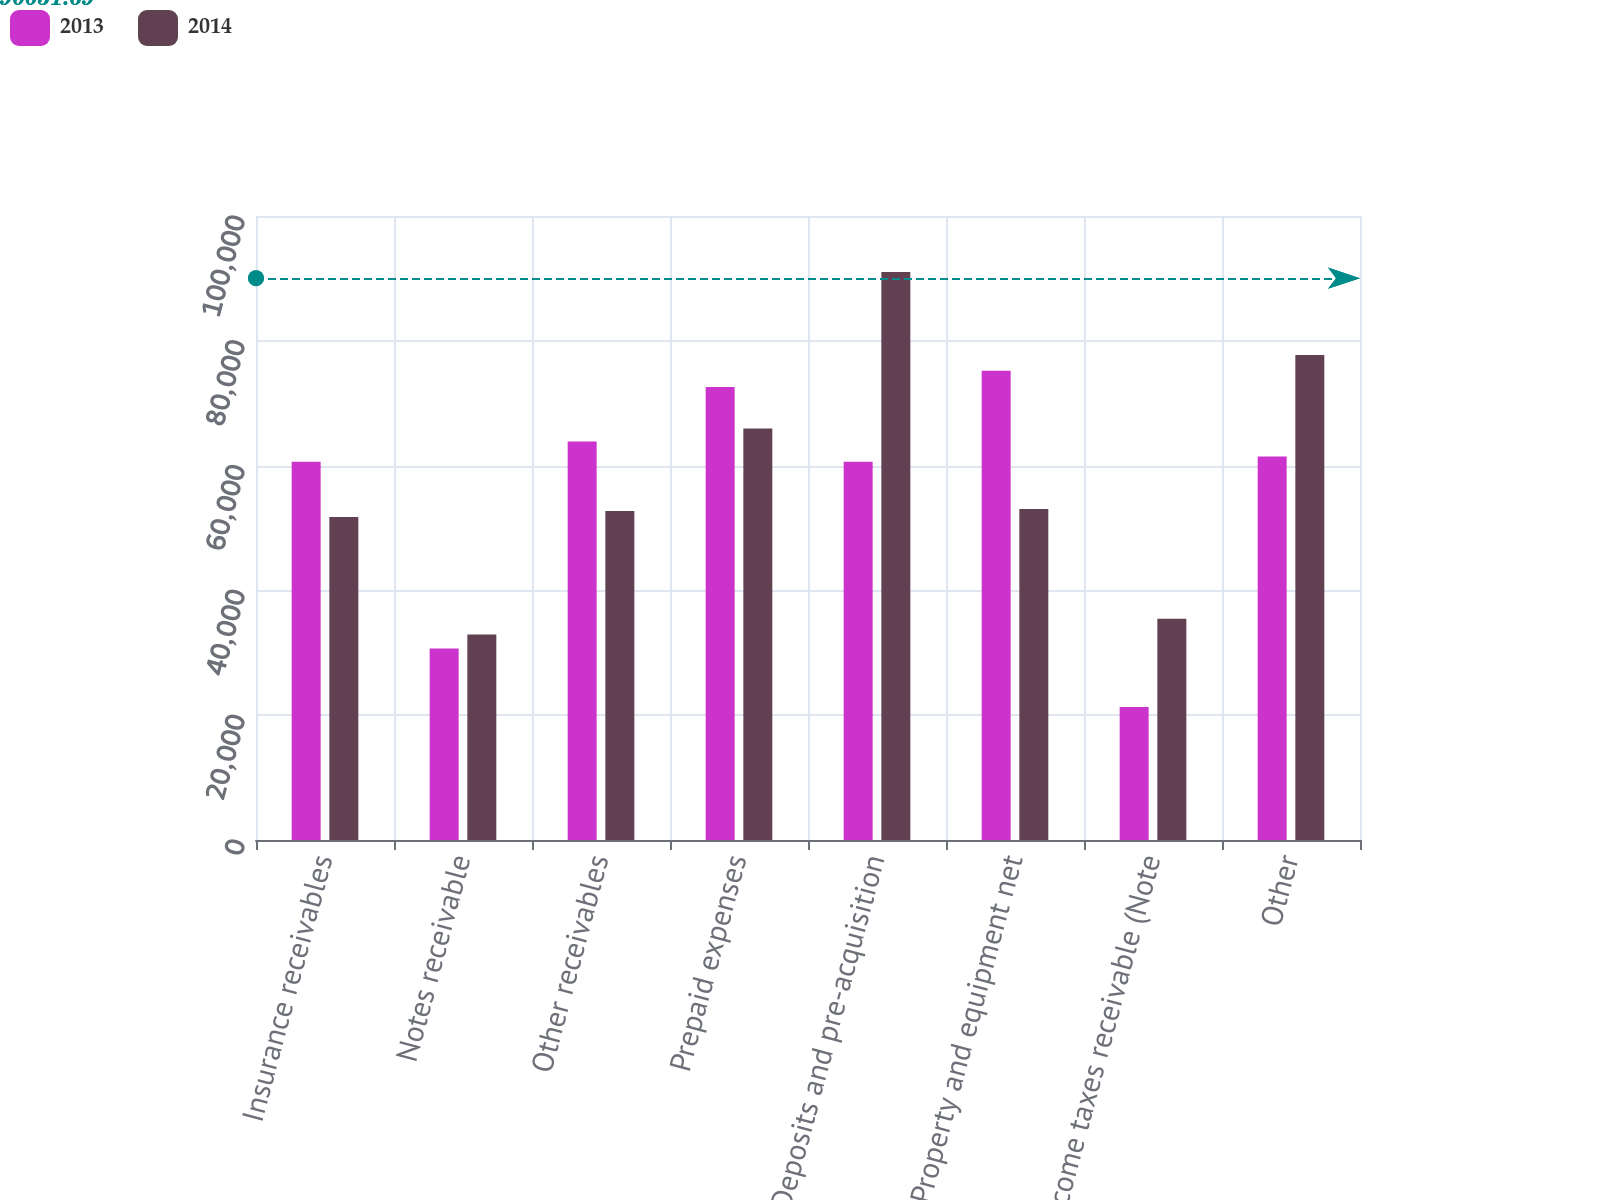Convert chart. <chart><loc_0><loc_0><loc_500><loc_500><stacked_bar_chart><ecel><fcel>Insurance receivables<fcel>Notes receivable<fcel>Other receivables<fcel>Prepaid expenses<fcel>Deposits and pre-acquisition<fcel>Property and equipment net<fcel>Income taxes receivable (Note<fcel>Other<nl><fcel>2013<fcel>60598<fcel>30699<fcel>63867<fcel>72585<fcel>60598<fcel>75219<fcel>21330<fcel>61454<nl><fcel>2014<fcel>51764<fcel>32944<fcel>52720<fcel>65965<fcel>91034<fcel>53051<fcel>35437<fcel>77706<nl></chart> 